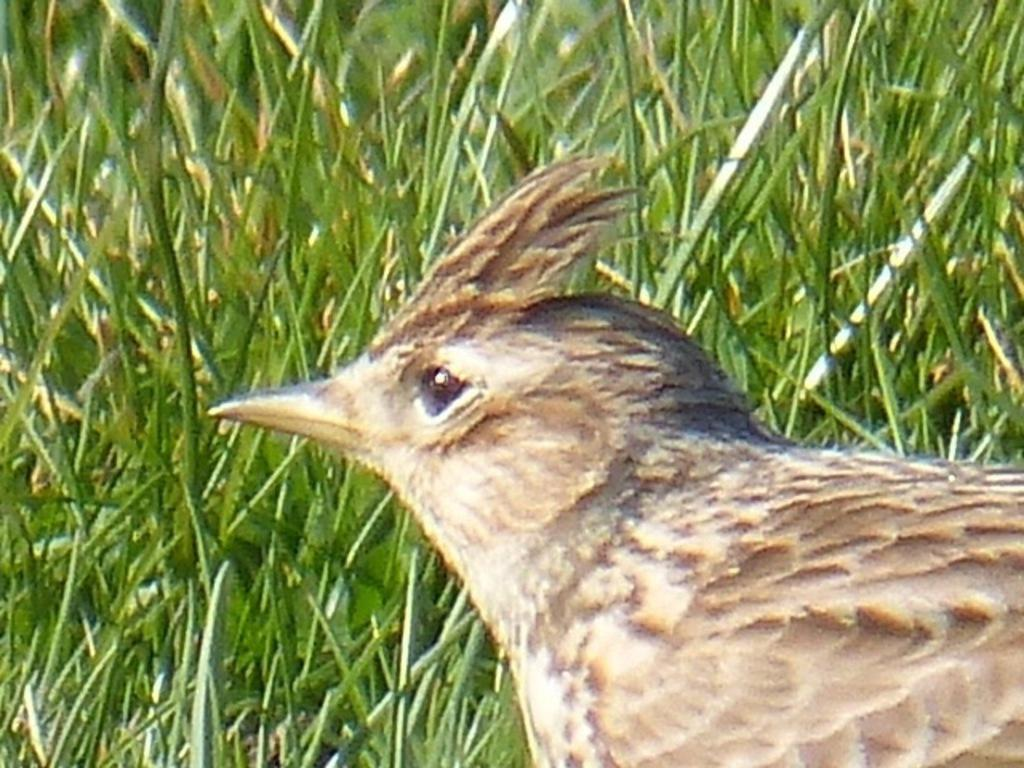What is the main subject of the image? There is a bird in the image. Where is the bird located in the image? The bird is in the middle of the image. What can be seen in the background of the image? There is grass in the background of the image. What is a distinctive feature of the bird? The bird has a long beak. What type of rod is the bird using to catch fish in the image? There is no rod present in the image, and the bird is not shown catching fish. 